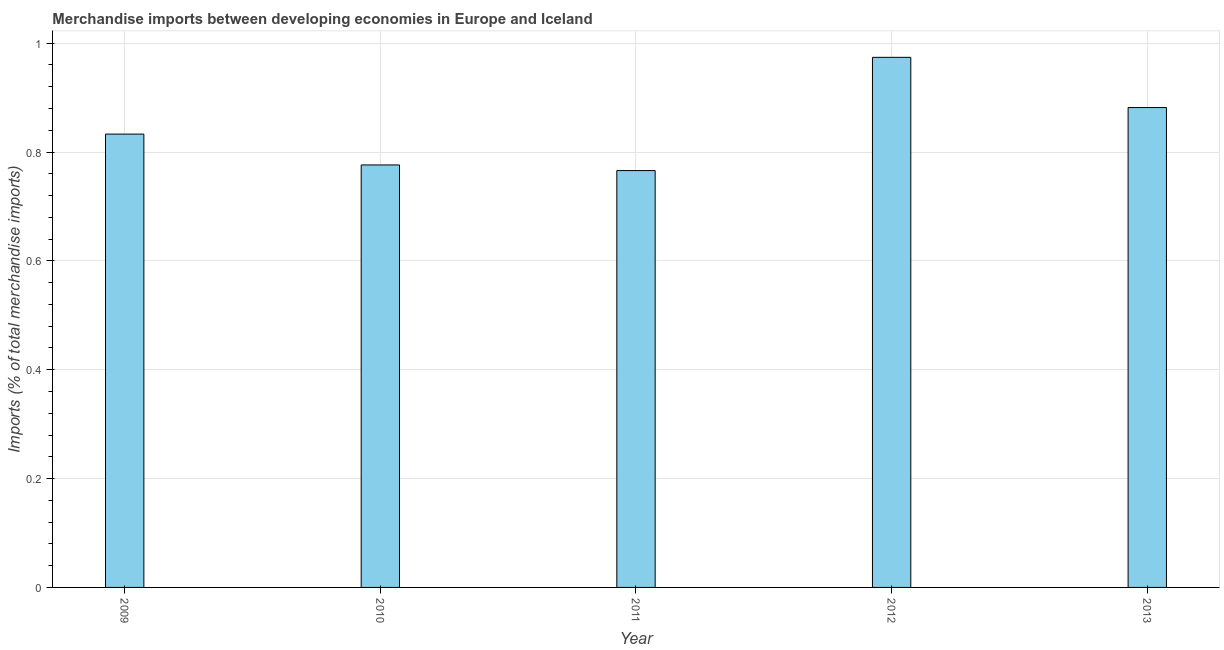Does the graph contain grids?
Ensure brevity in your answer.  Yes. What is the title of the graph?
Keep it short and to the point. Merchandise imports between developing economies in Europe and Iceland. What is the label or title of the Y-axis?
Your answer should be very brief. Imports (% of total merchandise imports). What is the merchandise imports in 2010?
Provide a succinct answer. 0.78. Across all years, what is the maximum merchandise imports?
Offer a very short reply. 0.97. Across all years, what is the minimum merchandise imports?
Your response must be concise. 0.77. What is the sum of the merchandise imports?
Make the answer very short. 4.23. What is the difference between the merchandise imports in 2011 and 2013?
Ensure brevity in your answer.  -0.12. What is the average merchandise imports per year?
Offer a very short reply. 0.85. What is the median merchandise imports?
Your response must be concise. 0.83. Do a majority of the years between 2010 and 2012 (inclusive) have merchandise imports greater than 0.64 %?
Keep it short and to the point. Yes. What is the ratio of the merchandise imports in 2009 to that in 2011?
Provide a succinct answer. 1.09. Is the difference between the merchandise imports in 2009 and 2012 greater than the difference between any two years?
Your answer should be compact. No. What is the difference between the highest and the second highest merchandise imports?
Your answer should be very brief. 0.09. Is the sum of the merchandise imports in 2009 and 2011 greater than the maximum merchandise imports across all years?
Your answer should be very brief. Yes. What is the difference between the highest and the lowest merchandise imports?
Your answer should be compact. 0.21. In how many years, is the merchandise imports greater than the average merchandise imports taken over all years?
Offer a terse response. 2. How many bars are there?
Your answer should be very brief. 5. How many years are there in the graph?
Make the answer very short. 5. Are the values on the major ticks of Y-axis written in scientific E-notation?
Give a very brief answer. No. What is the Imports (% of total merchandise imports) in 2009?
Your response must be concise. 0.83. What is the Imports (% of total merchandise imports) in 2010?
Your answer should be compact. 0.78. What is the Imports (% of total merchandise imports) in 2011?
Your response must be concise. 0.77. What is the Imports (% of total merchandise imports) in 2012?
Give a very brief answer. 0.97. What is the Imports (% of total merchandise imports) in 2013?
Keep it short and to the point. 0.88. What is the difference between the Imports (% of total merchandise imports) in 2009 and 2010?
Your answer should be compact. 0.06. What is the difference between the Imports (% of total merchandise imports) in 2009 and 2011?
Your answer should be very brief. 0.07. What is the difference between the Imports (% of total merchandise imports) in 2009 and 2012?
Give a very brief answer. -0.14. What is the difference between the Imports (% of total merchandise imports) in 2009 and 2013?
Your answer should be compact. -0.05. What is the difference between the Imports (% of total merchandise imports) in 2010 and 2011?
Your answer should be compact. 0.01. What is the difference between the Imports (% of total merchandise imports) in 2010 and 2012?
Keep it short and to the point. -0.2. What is the difference between the Imports (% of total merchandise imports) in 2010 and 2013?
Offer a very short reply. -0.11. What is the difference between the Imports (% of total merchandise imports) in 2011 and 2012?
Offer a very short reply. -0.21. What is the difference between the Imports (% of total merchandise imports) in 2011 and 2013?
Keep it short and to the point. -0.12. What is the difference between the Imports (% of total merchandise imports) in 2012 and 2013?
Keep it short and to the point. 0.09. What is the ratio of the Imports (% of total merchandise imports) in 2009 to that in 2010?
Provide a succinct answer. 1.07. What is the ratio of the Imports (% of total merchandise imports) in 2009 to that in 2011?
Your response must be concise. 1.09. What is the ratio of the Imports (% of total merchandise imports) in 2009 to that in 2012?
Provide a succinct answer. 0.85. What is the ratio of the Imports (% of total merchandise imports) in 2009 to that in 2013?
Your answer should be very brief. 0.94. What is the ratio of the Imports (% of total merchandise imports) in 2010 to that in 2012?
Keep it short and to the point. 0.8. What is the ratio of the Imports (% of total merchandise imports) in 2010 to that in 2013?
Your response must be concise. 0.88. What is the ratio of the Imports (% of total merchandise imports) in 2011 to that in 2012?
Keep it short and to the point. 0.79. What is the ratio of the Imports (% of total merchandise imports) in 2011 to that in 2013?
Give a very brief answer. 0.87. What is the ratio of the Imports (% of total merchandise imports) in 2012 to that in 2013?
Offer a very short reply. 1.1. 